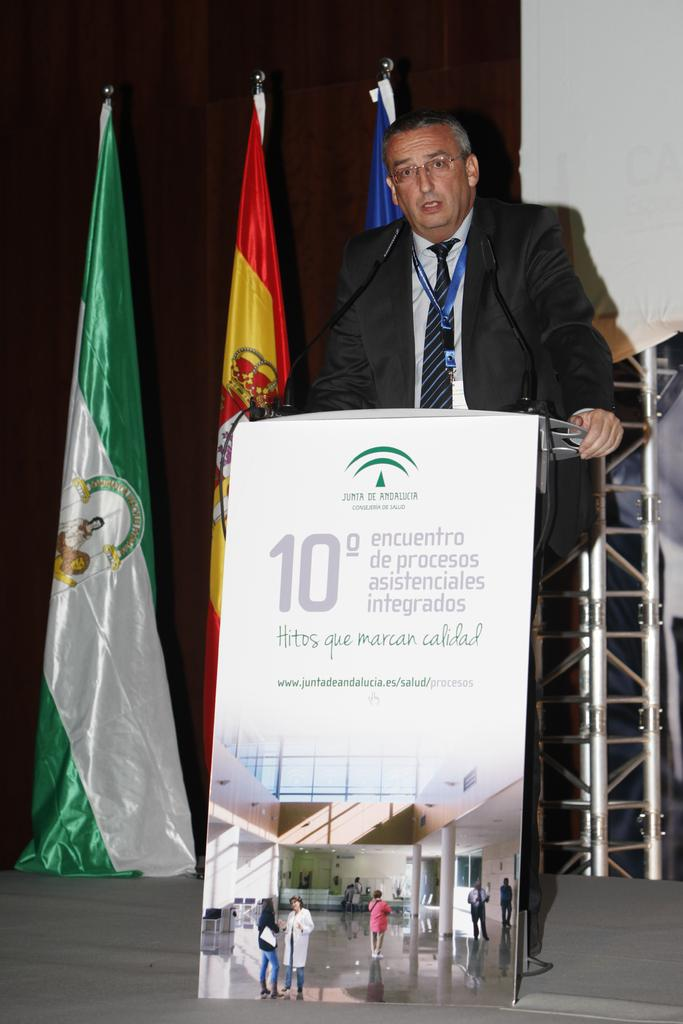What is the main subject of the image? There is a man standing in the image. What object is the man holding or interacting with? There is a microphone in the image. What other items can be seen in the image? There are flags and a poster in the image. What type of faucet is present in the image? There is no faucet present in the image. 